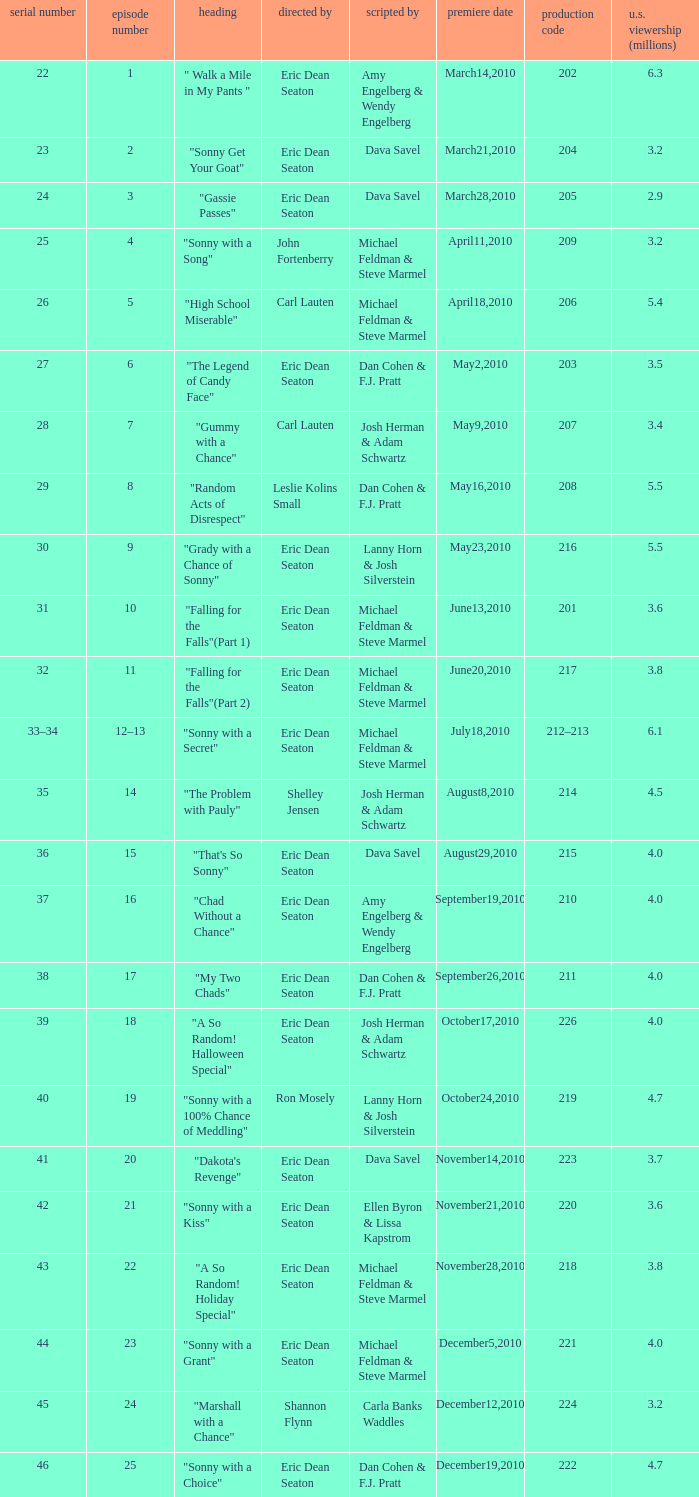Who directed the episode that 6.3 million u.s. viewers saw? Eric Dean Seaton. 